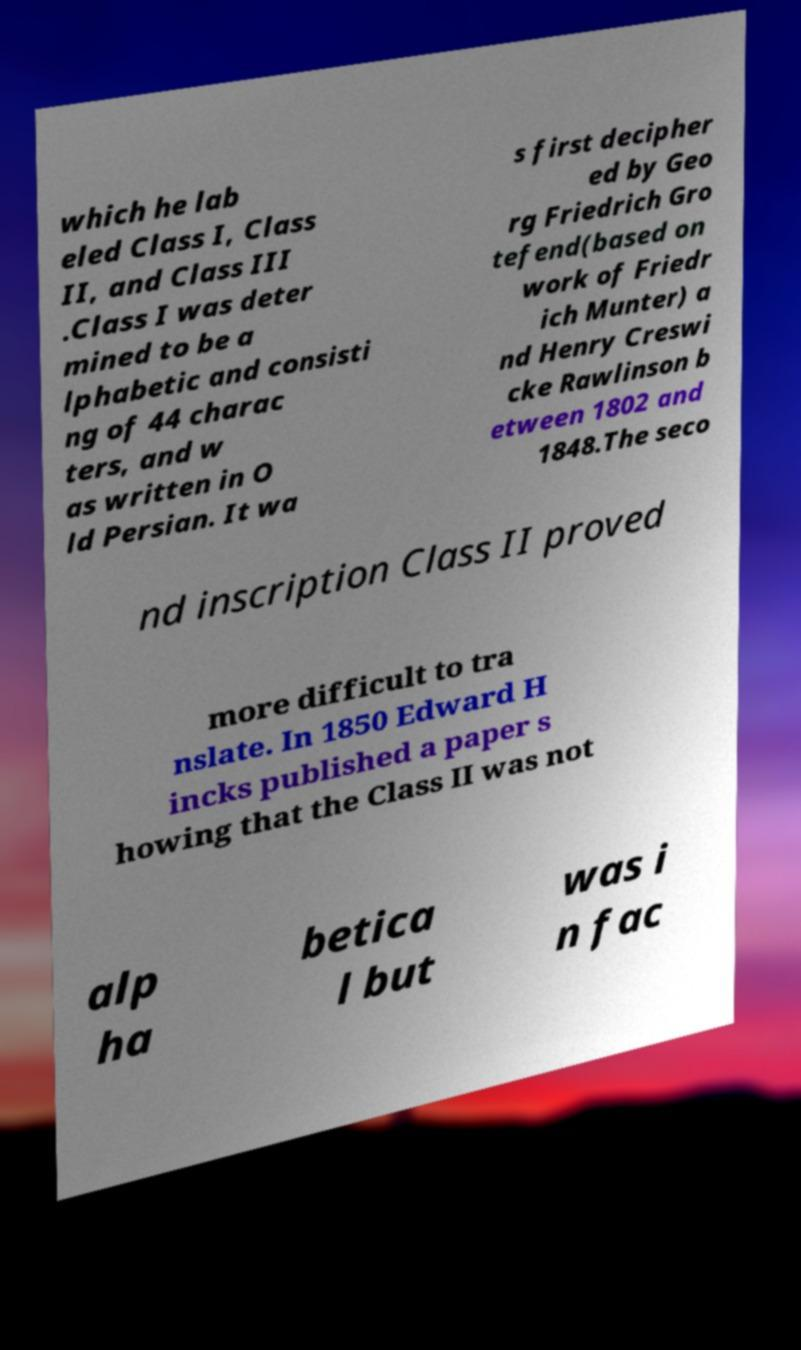For documentation purposes, I need the text within this image transcribed. Could you provide that? which he lab eled Class I, Class II, and Class III .Class I was deter mined to be a lphabetic and consisti ng of 44 charac ters, and w as written in O ld Persian. It wa s first decipher ed by Geo rg Friedrich Gro tefend(based on work of Friedr ich Munter) a nd Henry Creswi cke Rawlinson b etween 1802 and 1848.The seco nd inscription Class II proved more difficult to tra nslate. In 1850 Edward H incks published a paper s howing that the Class II was not alp ha betica l but was i n fac 